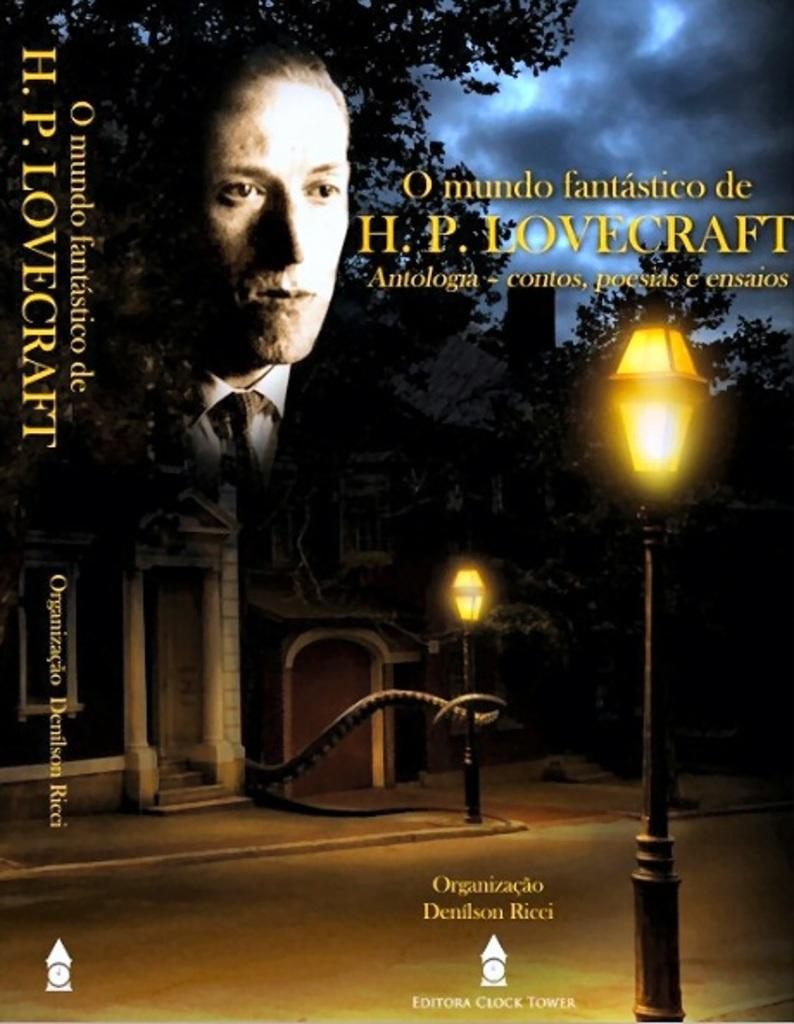<image>
Provide a brief description of the given image. The cover and spine of a book about HP Lovecraft. 